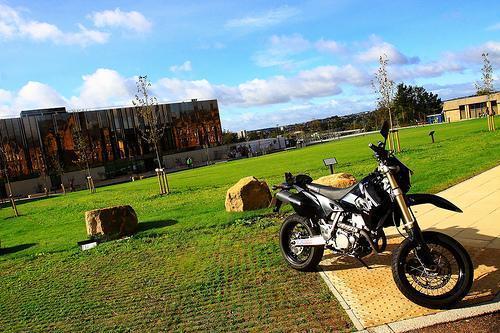How many motorcycles are shown?
Give a very brief answer. 1. How many wheels are on the motorcycle?
Give a very brief answer. 2. 